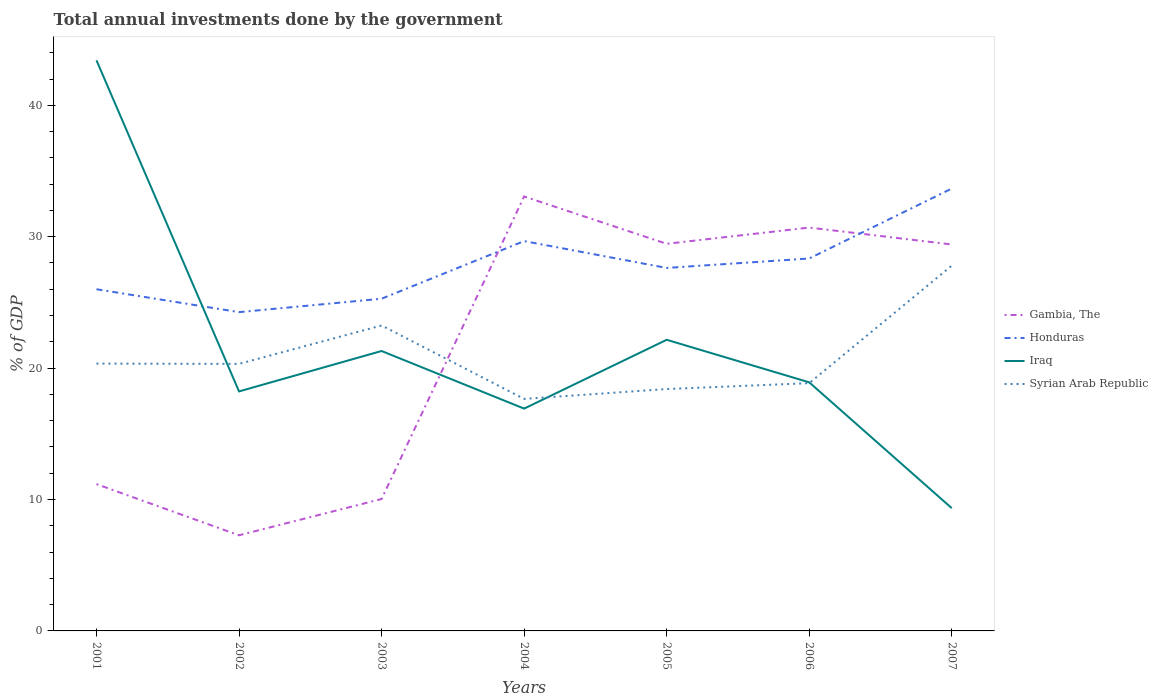Is the number of lines equal to the number of legend labels?
Your answer should be compact. Yes. Across all years, what is the maximum total annual investments done by the government in Gambia, The?
Your response must be concise. 7.28. In which year was the total annual investments done by the government in Iraq maximum?
Ensure brevity in your answer.  2007. What is the total total annual investments done by the government in Gambia, The in the graph?
Keep it short and to the point. 3.65. What is the difference between the highest and the second highest total annual investments done by the government in Syrian Arab Republic?
Make the answer very short. 10.14. What is the difference between the highest and the lowest total annual investments done by the government in Iraq?
Your response must be concise. 2. Is the total annual investments done by the government in Syrian Arab Republic strictly greater than the total annual investments done by the government in Gambia, The over the years?
Your answer should be compact. No. How many years are there in the graph?
Your answer should be very brief. 7. What is the difference between two consecutive major ticks on the Y-axis?
Provide a short and direct response. 10. Are the values on the major ticks of Y-axis written in scientific E-notation?
Your response must be concise. No. Does the graph contain any zero values?
Offer a terse response. No. How are the legend labels stacked?
Ensure brevity in your answer.  Vertical. What is the title of the graph?
Provide a succinct answer. Total annual investments done by the government. What is the label or title of the X-axis?
Provide a succinct answer. Years. What is the label or title of the Y-axis?
Ensure brevity in your answer.  % of GDP. What is the % of GDP of Gambia, The in 2001?
Ensure brevity in your answer.  11.17. What is the % of GDP of Honduras in 2001?
Your answer should be compact. 26. What is the % of GDP in Iraq in 2001?
Your answer should be compact. 43.42. What is the % of GDP in Syrian Arab Republic in 2001?
Ensure brevity in your answer.  20.34. What is the % of GDP of Gambia, The in 2002?
Provide a short and direct response. 7.28. What is the % of GDP of Honduras in 2002?
Offer a terse response. 24.26. What is the % of GDP in Iraq in 2002?
Offer a terse response. 18.23. What is the % of GDP of Syrian Arab Republic in 2002?
Provide a succinct answer. 20.32. What is the % of GDP of Gambia, The in 2003?
Provide a succinct answer. 10.04. What is the % of GDP in Honduras in 2003?
Give a very brief answer. 25.28. What is the % of GDP in Iraq in 2003?
Your response must be concise. 21.3. What is the % of GDP in Syrian Arab Republic in 2003?
Provide a short and direct response. 23.24. What is the % of GDP of Gambia, The in 2004?
Your response must be concise. 33.06. What is the % of GDP of Honduras in 2004?
Make the answer very short. 29.67. What is the % of GDP in Iraq in 2004?
Keep it short and to the point. 16.92. What is the % of GDP of Syrian Arab Republic in 2004?
Provide a short and direct response. 17.66. What is the % of GDP in Gambia, The in 2005?
Your answer should be compact. 29.46. What is the % of GDP in Honduras in 2005?
Your answer should be very brief. 27.62. What is the % of GDP of Iraq in 2005?
Your response must be concise. 22.16. What is the % of GDP of Syrian Arab Republic in 2005?
Keep it short and to the point. 18.41. What is the % of GDP of Gambia, The in 2006?
Provide a short and direct response. 30.7. What is the % of GDP of Honduras in 2006?
Keep it short and to the point. 28.34. What is the % of GDP in Iraq in 2006?
Make the answer very short. 18.92. What is the % of GDP of Syrian Arab Republic in 2006?
Your answer should be compact. 18.85. What is the % of GDP of Gambia, The in 2007?
Provide a short and direct response. 29.41. What is the % of GDP in Honduras in 2007?
Provide a short and direct response. 33.67. What is the % of GDP of Iraq in 2007?
Your response must be concise. 9.34. What is the % of GDP of Syrian Arab Republic in 2007?
Your answer should be compact. 27.8. Across all years, what is the maximum % of GDP in Gambia, The?
Keep it short and to the point. 33.06. Across all years, what is the maximum % of GDP in Honduras?
Ensure brevity in your answer.  33.67. Across all years, what is the maximum % of GDP in Iraq?
Keep it short and to the point. 43.42. Across all years, what is the maximum % of GDP in Syrian Arab Republic?
Your answer should be very brief. 27.8. Across all years, what is the minimum % of GDP of Gambia, The?
Your answer should be compact. 7.28. Across all years, what is the minimum % of GDP in Honduras?
Your answer should be very brief. 24.26. Across all years, what is the minimum % of GDP of Iraq?
Make the answer very short. 9.34. Across all years, what is the minimum % of GDP in Syrian Arab Republic?
Make the answer very short. 17.66. What is the total % of GDP of Gambia, The in the graph?
Give a very brief answer. 151.11. What is the total % of GDP in Honduras in the graph?
Keep it short and to the point. 194.84. What is the total % of GDP of Iraq in the graph?
Your answer should be compact. 150.28. What is the total % of GDP in Syrian Arab Republic in the graph?
Provide a succinct answer. 146.63. What is the difference between the % of GDP in Gambia, The in 2001 and that in 2002?
Your response must be concise. 3.89. What is the difference between the % of GDP of Honduras in 2001 and that in 2002?
Give a very brief answer. 1.74. What is the difference between the % of GDP in Iraq in 2001 and that in 2002?
Make the answer very short. 25.2. What is the difference between the % of GDP of Syrian Arab Republic in 2001 and that in 2002?
Your response must be concise. 0.02. What is the difference between the % of GDP of Gambia, The in 2001 and that in 2003?
Ensure brevity in your answer.  1.13. What is the difference between the % of GDP of Honduras in 2001 and that in 2003?
Give a very brief answer. 0.72. What is the difference between the % of GDP of Iraq in 2001 and that in 2003?
Ensure brevity in your answer.  22.12. What is the difference between the % of GDP of Syrian Arab Republic in 2001 and that in 2003?
Your response must be concise. -2.9. What is the difference between the % of GDP of Gambia, The in 2001 and that in 2004?
Your response must be concise. -21.89. What is the difference between the % of GDP in Honduras in 2001 and that in 2004?
Offer a very short reply. -3.66. What is the difference between the % of GDP of Iraq in 2001 and that in 2004?
Make the answer very short. 26.51. What is the difference between the % of GDP in Syrian Arab Republic in 2001 and that in 2004?
Give a very brief answer. 2.69. What is the difference between the % of GDP of Gambia, The in 2001 and that in 2005?
Keep it short and to the point. -18.29. What is the difference between the % of GDP of Honduras in 2001 and that in 2005?
Make the answer very short. -1.62. What is the difference between the % of GDP of Iraq in 2001 and that in 2005?
Your answer should be compact. 21.27. What is the difference between the % of GDP of Syrian Arab Republic in 2001 and that in 2005?
Provide a succinct answer. 1.94. What is the difference between the % of GDP in Gambia, The in 2001 and that in 2006?
Ensure brevity in your answer.  -19.52. What is the difference between the % of GDP of Honduras in 2001 and that in 2006?
Offer a terse response. -2.34. What is the difference between the % of GDP of Iraq in 2001 and that in 2006?
Provide a short and direct response. 24.5. What is the difference between the % of GDP of Syrian Arab Republic in 2001 and that in 2006?
Provide a short and direct response. 1.49. What is the difference between the % of GDP in Gambia, The in 2001 and that in 2007?
Give a very brief answer. -18.24. What is the difference between the % of GDP in Honduras in 2001 and that in 2007?
Offer a very short reply. -7.66. What is the difference between the % of GDP of Iraq in 2001 and that in 2007?
Give a very brief answer. 34.08. What is the difference between the % of GDP in Syrian Arab Republic in 2001 and that in 2007?
Give a very brief answer. -7.45. What is the difference between the % of GDP in Gambia, The in 2002 and that in 2003?
Offer a terse response. -2.76. What is the difference between the % of GDP in Honduras in 2002 and that in 2003?
Your answer should be very brief. -1.02. What is the difference between the % of GDP of Iraq in 2002 and that in 2003?
Your answer should be compact. -3.08. What is the difference between the % of GDP of Syrian Arab Republic in 2002 and that in 2003?
Your answer should be compact. -2.92. What is the difference between the % of GDP of Gambia, The in 2002 and that in 2004?
Your answer should be compact. -25.78. What is the difference between the % of GDP of Honduras in 2002 and that in 2004?
Your answer should be compact. -5.41. What is the difference between the % of GDP of Iraq in 2002 and that in 2004?
Offer a terse response. 1.31. What is the difference between the % of GDP in Syrian Arab Republic in 2002 and that in 2004?
Offer a terse response. 2.66. What is the difference between the % of GDP in Gambia, The in 2002 and that in 2005?
Give a very brief answer. -22.18. What is the difference between the % of GDP of Honduras in 2002 and that in 2005?
Your answer should be very brief. -3.36. What is the difference between the % of GDP in Iraq in 2002 and that in 2005?
Provide a short and direct response. -3.93. What is the difference between the % of GDP in Syrian Arab Republic in 2002 and that in 2005?
Make the answer very short. 1.91. What is the difference between the % of GDP in Gambia, The in 2002 and that in 2006?
Make the answer very short. -23.42. What is the difference between the % of GDP in Honduras in 2002 and that in 2006?
Provide a short and direct response. -4.08. What is the difference between the % of GDP of Iraq in 2002 and that in 2006?
Your response must be concise. -0.69. What is the difference between the % of GDP in Syrian Arab Republic in 2002 and that in 2006?
Your response must be concise. 1.47. What is the difference between the % of GDP of Gambia, The in 2002 and that in 2007?
Give a very brief answer. -22.13. What is the difference between the % of GDP of Honduras in 2002 and that in 2007?
Provide a succinct answer. -9.41. What is the difference between the % of GDP in Iraq in 2002 and that in 2007?
Make the answer very short. 8.89. What is the difference between the % of GDP in Syrian Arab Republic in 2002 and that in 2007?
Offer a very short reply. -7.48. What is the difference between the % of GDP of Gambia, The in 2003 and that in 2004?
Your answer should be compact. -23.02. What is the difference between the % of GDP in Honduras in 2003 and that in 2004?
Your response must be concise. -4.38. What is the difference between the % of GDP in Iraq in 2003 and that in 2004?
Make the answer very short. 4.38. What is the difference between the % of GDP of Syrian Arab Republic in 2003 and that in 2004?
Give a very brief answer. 5.59. What is the difference between the % of GDP of Gambia, The in 2003 and that in 2005?
Your response must be concise. -19.42. What is the difference between the % of GDP of Honduras in 2003 and that in 2005?
Your answer should be compact. -2.34. What is the difference between the % of GDP in Iraq in 2003 and that in 2005?
Provide a succinct answer. -0.85. What is the difference between the % of GDP of Syrian Arab Republic in 2003 and that in 2005?
Provide a short and direct response. 4.84. What is the difference between the % of GDP of Gambia, The in 2003 and that in 2006?
Ensure brevity in your answer.  -20.66. What is the difference between the % of GDP of Honduras in 2003 and that in 2006?
Keep it short and to the point. -3.06. What is the difference between the % of GDP of Iraq in 2003 and that in 2006?
Give a very brief answer. 2.38. What is the difference between the % of GDP of Syrian Arab Republic in 2003 and that in 2006?
Keep it short and to the point. 4.39. What is the difference between the % of GDP of Gambia, The in 2003 and that in 2007?
Keep it short and to the point. -19.37. What is the difference between the % of GDP of Honduras in 2003 and that in 2007?
Keep it short and to the point. -8.38. What is the difference between the % of GDP in Iraq in 2003 and that in 2007?
Give a very brief answer. 11.96. What is the difference between the % of GDP of Syrian Arab Republic in 2003 and that in 2007?
Your response must be concise. -4.55. What is the difference between the % of GDP of Gambia, The in 2004 and that in 2005?
Ensure brevity in your answer.  3.6. What is the difference between the % of GDP of Honduras in 2004 and that in 2005?
Give a very brief answer. 2.04. What is the difference between the % of GDP of Iraq in 2004 and that in 2005?
Offer a very short reply. -5.24. What is the difference between the % of GDP in Syrian Arab Republic in 2004 and that in 2005?
Ensure brevity in your answer.  -0.75. What is the difference between the % of GDP of Gambia, The in 2004 and that in 2006?
Give a very brief answer. 2.36. What is the difference between the % of GDP in Honduras in 2004 and that in 2006?
Provide a succinct answer. 1.32. What is the difference between the % of GDP of Iraq in 2004 and that in 2006?
Make the answer very short. -2. What is the difference between the % of GDP of Syrian Arab Republic in 2004 and that in 2006?
Ensure brevity in your answer.  -1.2. What is the difference between the % of GDP in Gambia, The in 2004 and that in 2007?
Your answer should be very brief. 3.65. What is the difference between the % of GDP of Honduras in 2004 and that in 2007?
Provide a succinct answer. -4. What is the difference between the % of GDP in Iraq in 2004 and that in 2007?
Keep it short and to the point. 7.58. What is the difference between the % of GDP in Syrian Arab Republic in 2004 and that in 2007?
Keep it short and to the point. -10.14. What is the difference between the % of GDP in Gambia, The in 2005 and that in 2006?
Provide a succinct answer. -1.24. What is the difference between the % of GDP of Honduras in 2005 and that in 2006?
Your answer should be compact. -0.72. What is the difference between the % of GDP in Iraq in 2005 and that in 2006?
Keep it short and to the point. 3.24. What is the difference between the % of GDP in Syrian Arab Republic in 2005 and that in 2006?
Provide a short and direct response. -0.45. What is the difference between the % of GDP of Gambia, The in 2005 and that in 2007?
Offer a terse response. 0.05. What is the difference between the % of GDP of Honduras in 2005 and that in 2007?
Your response must be concise. -6.04. What is the difference between the % of GDP of Iraq in 2005 and that in 2007?
Give a very brief answer. 12.81. What is the difference between the % of GDP of Syrian Arab Republic in 2005 and that in 2007?
Make the answer very short. -9.39. What is the difference between the % of GDP in Gambia, The in 2006 and that in 2007?
Your answer should be very brief. 1.29. What is the difference between the % of GDP in Honduras in 2006 and that in 2007?
Offer a terse response. -5.32. What is the difference between the % of GDP of Iraq in 2006 and that in 2007?
Your answer should be very brief. 9.58. What is the difference between the % of GDP in Syrian Arab Republic in 2006 and that in 2007?
Your answer should be very brief. -8.94. What is the difference between the % of GDP in Gambia, The in 2001 and the % of GDP in Honduras in 2002?
Give a very brief answer. -13.09. What is the difference between the % of GDP of Gambia, The in 2001 and the % of GDP of Iraq in 2002?
Keep it short and to the point. -7.05. What is the difference between the % of GDP of Gambia, The in 2001 and the % of GDP of Syrian Arab Republic in 2002?
Your answer should be very brief. -9.15. What is the difference between the % of GDP in Honduras in 2001 and the % of GDP in Iraq in 2002?
Make the answer very short. 7.77. What is the difference between the % of GDP in Honduras in 2001 and the % of GDP in Syrian Arab Republic in 2002?
Ensure brevity in your answer.  5.68. What is the difference between the % of GDP of Iraq in 2001 and the % of GDP of Syrian Arab Republic in 2002?
Your response must be concise. 23.1. What is the difference between the % of GDP in Gambia, The in 2001 and the % of GDP in Honduras in 2003?
Keep it short and to the point. -14.11. What is the difference between the % of GDP in Gambia, The in 2001 and the % of GDP in Iraq in 2003?
Offer a very short reply. -10.13. What is the difference between the % of GDP of Gambia, The in 2001 and the % of GDP of Syrian Arab Republic in 2003?
Offer a very short reply. -12.07. What is the difference between the % of GDP of Honduras in 2001 and the % of GDP of Iraq in 2003?
Your answer should be compact. 4.7. What is the difference between the % of GDP of Honduras in 2001 and the % of GDP of Syrian Arab Republic in 2003?
Your answer should be compact. 2.76. What is the difference between the % of GDP in Iraq in 2001 and the % of GDP in Syrian Arab Republic in 2003?
Give a very brief answer. 20.18. What is the difference between the % of GDP in Gambia, The in 2001 and the % of GDP in Honduras in 2004?
Make the answer very short. -18.49. What is the difference between the % of GDP of Gambia, The in 2001 and the % of GDP of Iraq in 2004?
Your answer should be compact. -5.74. What is the difference between the % of GDP of Gambia, The in 2001 and the % of GDP of Syrian Arab Republic in 2004?
Ensure brevity in your answer.  -6.48. What is the difference between the % of GDP in Honduras in 2001 and the % of GDP in Iraq in 2004?
Make the answer very short. 9.08. What is the difference between the % of GDP in Honduras in 2001 and the % of GDP in Syrian Arab Republic in 2004?
Offer a terse response. 8.34. What is the difference between the % of GDP of Iraq in 2001 and the % of GDP of Syrian Arab Republic in 2004?
Provide a succinct answer. 25.77. What is the difference between the % of GDP of Gambia, The in 2001 and the % of GDP of Honduras in 2005?
Make the answer very short. -16.45. What is the difference between the % of GDP of Gambia, The in 2001 and the % of GDP of Iraq in 2005?
Offer a very short reply. -10.98. What is the difference between the % of GDP of Gambia, The in 2001 and the % of GDP of Syrian Arab Republic in 2005?
Ensure brevity in your answer.  -7.23. What is the difference between the % of GDP of Honduras in 2001 and the % of GDP of Iraq in 2005?
Provide a succinct answer. 3.85. What is the difference between the % of GDP of Honduras in 2001 and the % of GDP of Syrian Arab Republic in 2005?
Offer a terse response. 7.59. What is the difference between the % of GDP of Iraq in 2001 and the % of GDP of Syrian Arab Republic in 2005?
Your answer should be compact. 25.02. What is the difference between the % of GDP of Gambia, The in 2001 and the % of GDP of Honduras in 2006?
Keep it short and to the point. -17.17. What is the difference between the % of GDP in Gambia, The in 2001 and the % of GDP in Iraq in 2006?
Your response must be concise. -7.74. What is the difference between the % of GDP in Gambia, The in 2001 and the % of GDP in Syrian Arab Republic in 2006?
Offer a terse response. -7.68. What is the difference between the % of GDP of Honduras in 2001 and the % of GDP of Iraq in 2006?
Make the answer very short. 7.08. What is the difference between the % of GDP in Honduras in 2001 and the % of GDP in Syrian Arab Republic in 2006?
Make the answer very short. 7.15. What is the difference between the % of GDP of Iraq in 2001 and the % of GDP of Syrian Arab Republic in 2006?
Provide a short and direct response. 24.57. What is the difference between the % of GDP in Gambia, The in 2001 and the % of GDP in Honduras in 2007?
Give a very brief answer. -22.49. What is the difference between the % of GDP of Gambia, The in 2001 and the % of GDP of Iraq in 2007?
Offer a very short reply. 1.83. What is the difference between the % of GDP of Gambia, The in 2001 and the % of GDP of Syrian Arab Republic in 2007?
Keep it short and to the point. -16.63. What is the difference between the % of GDP in Honduras in 2001 and the % of GDP in Iraq in 2007?
Make the answer very short. 16.66. What is the difference between the % of GDP in Honduras in 2001 and the % of GDP in Syrian Arab Republic in 2007?
Provide a short and direct response. -1.8. What is the difference between the % of GDP in Iraq in 2001 and the % of GDP in Syrian Arab Republic in 2007?
Keep it short and to the point. 15.62. What is the difference between the % of GDP of Gambia, The in 2002 and the % of GDP of Honduras in 2003?
Offer a very short reply. -18. What is the difference between the % of GDP of Gambia, The in 2002 and the % of GDP of Iraq in 2003?
Your answer should be very brief. -14.02. What is the difference between the % of GDP of Gambia, The in 2002 and the % of GDP of Syrian Arab Republic in 2003?
Offer a very short reply. -15.97. What is the difference between the % of GDP of Honduras in 2002 and the % of GDP of Iraq in 2003?
Offer a terse response. 2.96. What is the difference between the % of GDP in Honduras in 2002 and the % of GDP in Syrian Arab Republic in 2003?
Provide a short and direct response. 1.01. What is the difference between the % of GDP of Iraq in 2002 and the % of GDP of Syrian Arab Republic in 2003?
Offer a terse response. -5.02. What is the difference between the % of GDP of Gambia, The in 2002 and the % of GDP of Honduras in 2004?
Give a very brief answer. -22.39. What is the difference between the % of GDP of Gambia, The in 2002 and the % of GDP of Iraq in 2004?
Your answer should be compact. -9.64. What is the difference between the % of GDP in Gambia, The in 2002 and the % of GDP in Syrian Arab Republic in 2004?
Ensure brevity in your answer.  -10.38. What is the difference between the % of GDP of Honduras in 2002 and the % of GDP of Iraq in 2004?
Your answer should be compact. 7.34. What is the difference between the % of GDP in Honduras in 2002 and the % of GDP in Syrian Arab Republic in 2004?
Your answer should be compact. 6.6. What is the difference between the % of GDP in Iraq in 2002 and the % of GDP in Syrian Arab Republic in 2004?
Provide a short and direct response. 0.57. What is the difference between the % of GDP in Gambia, The in 2002 and the % of GDP in Honduras in 2005?
Ensure brevity in your answer.  -20.34. What is the difference between the % of GDP in Gambia, The in 2002 and the % of GDP in Iraq in 2005?
Ensure brevity in your answer.  -14.88. What is the difference between the % of GDP in Gambia, The in 2002 and the % of GDP in Syrian Arab Republic in 2005?
Make the answer very short. -11.13. What is the difference between the % of GDP of Honduras in 2002 and the % of GDP of Iraq in 2005?
Your response must be concise. 2.1. What is the difference between the % of GDP in Honduras in 2002 and the % of GDP in Syrian Arab Republic in 2005?
Provide a succinct answer. 5.85. What is the difference between the % of GDP of Iraq in 2002 and the % of GDP of Syrian Arab Republic in 2005?
Your answer should be compact. -0.18. What is the difference between the % of GDP of Gambia, The in 2002 and the % of GDP of Honduras in 2006?
Provide a succinct answer. -21.06. What is the difference between the % of GDP in Gambia, The in 2002 and the % of GDP in Iraq in 2006?
Provide a short and direct response. -11.64. What is the difference between the % of GDP in Gambia, The in 2002 and the % of GDP in Syrian Arab Republic in 2006?
Provide a short and direct response. -11.58. What is the difference between the % of GDP in Honduras in 2002 and the % of GDP in Iraq in 2006?
Provide a short and direct response. 5.34. What is the difference between the % of GDP in Honduras in 2002 and the % of GDP in Syrian Arab Republic in 2006?
Offer a very short reply. 5.4. What is the difference between the % of GDP of Iraq in 2002 and the % of GDP of Syrian Arab Republic in 2006?
Provide a short and direct response. -0.63. What is the difference between the % of GDP in Gambia, The in 2002 and the % of GDP in Honduras in 2007?
Ensure brevity in your answer.  -26.39. What is the difference between the % of GDP in Gambia, The in 2002 and the % of GDP in Iraq in 2007?
Provide a short and direct response. -2.06. What is the difference between the % of GDP of Gambia, The in 2002 and the % of GDP of Syrian Arab Republic in 2007?
Provide a succinct answer. -20.52. What is the difference between the % of GDP of Honduras in 2002 and the % of GDP of Iraq in 2007?
Offer a terse response. 14.92. What is the difference between the % of GDP in Honduras in 2002 and the % of GDP in Syrian Arab Republic in 2007?
Provide a succinct answer. -3.54. What is the difference between the % of GDP of Iraq in 2002 and the % of GDP of Syrian Arab Republic in 2007?
Make the answer very short. -9.57. What is the difference between the % of GDP of Gambia, The in 2003 and the % of GDP of Honduras in 2004?
Keep it short and to the point. -19.63. What is the difference between the % of GDP of Gambia, The in 2003 and the % of GDP of Iraq in 2004?
Ensure brevity in your answer.  -6.88. What is the difference between the % of GDP of Gambia, The in 2003 and the % of GDP of Syrian Arab Republic in 2004?
Your answer should be compact. -7.62. What is the difference between the % of GDP in Honduras in 2003 and the % of GDP in Iraq in 2004?
Your answer should be compact. 8.36. What is the difference between the % of GDP of Honduras in 2003 and the % of GDP of Syrian Arab Republic in 2004?
Your response must be concise. 7.62. What is the difference between the % of GDP in Iraq in 2003 and the % of GDP in Syrian Arab Republic in 2004?
Your response must be concise. 3.65. What is the difference between the % of GDP in Gambia, The in 2003 and the % of GDP in Honduras in 2005?
Provide a succinct answer. -17.58. What is the difference between the % of GDP in Gambia, The in 2003 and the % of GDP in Iraq in 2005?
Offer a very short reply. -12.12. What is the difference between the % of GDP in Gambia, The in 2003 and the % of GDP in Syrian Arab Republic in 2005?
Provide a succinct answer. -8.37. What is the difference between the % of GDP of Honduras in 2003 and the % of GDP of Iraq in 2005?
Your answer should be very brief. 3.13. What is the difference between the % of GDP in Honduras in 2003 and the % of GDP in Syrian Arab Republic in 2005?
Keep it short and to the point. 6.87. What is the difference between the % of GDP of Iraq in 2003 and the % of GDP of Syrian Arab Republic in 2005?
Keep it short and to the point. 2.9. What is the difference between the % of GDP of Gambia, The in 2003 and the % of GDP of Honduras in 2006?
Ensure brevity in your answer.  -18.3. What is the difference between the % of GDP in Gambia, The in 2003 and the % of GDP in Iraq in 2006?
Your response must be concise. -8.88. What is the difference between the % of GDP in Gambia, The in 2003 and the % of GDP in Syrian Arab Republic in 2006?
Your answer should be very brief. -8.82. What is the difference between the % of GDP of Honduras in 2003 and the % of GDP of Iraq in 2006?
Keep it short and to the point. 6.36. What is the difference between the % of GDP in Honduras in 2003 and the % of GDP in Syrian Arab Republic in 2006?
Provide a succinct answer. 6.43. What is the difference between the % of GDP in Iraq in 2003 and the % of GDP in Syrian Arab Republic in 2006?
Give a very brief answer. 2.45. What is the difference between the % of GDP of Gambia, The in 2003 and the % of GDP of Honduras in 2007?
Provide a succinct answer. -23.63. What is the difference between the % of GDP in Gambia, The in 2003 and the % of GDP in Iraq in 2007?
Provide a succinct answer. 0.7. What is the difference between the % of GDP of Gambia, The in 2003 and the % of GDP of Syrian Arab Republic in 2007?
Ensure brevity in your answer.  -17.76. What is the difference between the % of GDP in Honduras in 2003 and the % of GDP in Iraq in 2007?
Ensure brevity in your answer.  15.94. What is the difference between the % of GDP of Honduras in 2003 and the % of GDP of Syrian Arab Republic in 2007?
Offer a very short reply. -2.52. What is the difference between the % of GDP in Iraq in 2003 and the % of GDP in Syrian Arab Republic in 2007?
Offer a very short reply. -6.5. What is the difference between the % of GDP of Gambia, The in 2004 and the % of GDP of Honduras in 2005?
Your answer should be very brief. 5.44. What is the difference between the % of GDP of Gambia, The in 2004 and the % of GDP of Iraq in 2005?
Provide a succinct answer. 10.9. What is the difference between the % of GDP of Gambia, The in 2004 and the % of GDP of Syrian Arab Republic in 2005?
Ensure brevity in your answer.  14.65. What is the difference between the % of GDP in Honduras in 2004 and the % of GDP in Iraq in 2005?
Provide a succinct answer. 7.51. What is the difference between the % of GDP in Honduras in 2004 and the % of GDP in Syrian Arab Republic in 2005?
Offer a terse response. 11.26. What is the difference between the % of GDP in Iraq in 2004 and the % of GDP in Syrian Arab Republic in 2005?
Provide a succinct answer. -1.49. What is the difference between the % of GDP in Gambia, The in 2004 and the % of GDP in Honduras in 2006?
Provide a short and direct response. 4.72. What is the difference between the % of GDP in Gambia, The in 2004 and the % of GDP in Iraq in 2006?
Keep it short and to the point. 14.14. What is the difference between the % of GDP of Gambia, The in 2004 and the % of GDP of Syrian Arab Republic in 2006?
Provide a short and direct response. 14.21. What is the difference between the % of GDP in Honduras in 2004 and the % of GDP in Iraq in 2006?
Offer a terse response. 10.75. What is the difference between the % of GDP in Honduras in 2004 and the % of GDP in Syrian Arab Republic in 2006?
Keep it short and to the point. 10.81. What is the difference between the % of GDP of Iraq in 2004 and the % of GDP of Syrian Arab Republic in 2006?
Keep it short and to the point. -1.94. What is the difference between the % of GDP in Gambia, The in 2004 and the % of GDP in Honduras in 2007?
Keep it short and to the point. -0.61. What is the difference between the % of GDP of Gambia, The in 2004 and the % of GDP of Iraq in 2007?
Make the answer very short. 23.72. What is the difference between the % of GDP in Gambia, The in 2004 and the % of GDP in Syrian Arab Republic in 2007?
Provide a succinct answer. 5.26. What is the difference between the % of GDP of Honduras in 2004 and the % of GDP of Iraq in 2007?
Your answer should be compact. 20.32. What is the difference between the % of GDP of Honduras in 2004 and the % of GDP of Syrian Arab Republic in 2007?
Provide a succinct answer. 1.87. What is the difference between the % of GDP of Iraq in 2004 and the % of GDP of Syrian Arab Republic in 2007?
Give a very brief answer. -10.88. What is the difference between the % of GDP of Gambia, The in 2005 and the % of GDP of Honduras in 2006?
Your response must be concise. 1.12. What is the difference between the % of GDP in Gambia, The in 2005 and the % of GDP in Iraq in 2006?
Give a very brief answer. 10.54. What is the difference between the % of GDP of Gambia, The in 2005 and the % of GDP of Syrian Arab Republic in 2006?
Your answer should be very brief. 10.61. What is the difference between the % of GDP in Honduras in 2005 and the % of GDP in Iraq in 2006?
Provide a succinct answer. 8.71. What is the difference between the % of GDP in Honduras in 2005 and the % of GDP in Syrian Arab Republic in 2006?
Your answer should be very brief. 8.77. What is the difference between the % of GDP of Iraq in 2005 and the % of GDP of Syrian Arab Republic in 2006?
Give a very brief answer. 3.3. What is the difference between the % of GDP of Gambia, The in 2005 and the % of GDP of Honduras in 2007?
Offer a terse response. -4.21. What is the difference between the % of GDP of Gambia, The in 2005 and the % of GDP of Iraq in 2007?
Make the answer very short. 20.12. What is the difference between the % of GDP of Gambia, The in 2005 and the % of GDP of Syrian Arab Republic in 2007?
Give a very brief answer. 1.66. What is the difference between the % of GDP in Honduras in 2005 and the % of GDP in Iraq in 2007?
Offer a very short reply. 18.28. What is the difference between the % of GDP of Honduras in 2005 and the % of GDP of Syrian Arab Republic in 2007?
Give a very brief answer. -0.18. What is the difference between the % of GDP in Iraq in 2005 and the % of GDP in Syrian Arab Republic in 2007?
Your response must be concise. -5.64. What is the difference between the % of GDP in Gambia, The in 2006 and the % of GDP in Honduras in 2007?
Your answer should be very brief. -2.97. What is the difference between the % of GDP in Gambia, The in 2006 and the % of GDP in Iraq in 2007?
Keep it short and to the point. 21.35. What is the difference between the % of GDP of Gambia, The in 2006 and the % of GDP of Syrian Arab Republic in 2007?
Give a very brief answer. 2.9. What is the difference between the % of GDP in Honduras in 2006 and the % of GDP in Iraq in 2007?
Give a very brief answer. 19. What is the difference between the % of GDP in Honduras in 2006 and the % of GDP in Syrian Arab Republic in 2007?
Give a very brief answer. 0.54. What is the difference between the % of GDP of Iraq in 2006 and the % of GDP of Syrian Arab Republic in 2007?
Keep it short and to the point. -8.88. What is the average % of GDP of Gambia, The per year?
Your answer should be compact. 21.59. What is the average % of GDP in Honduras per year?
Your response must be concise. 27.83. What is the average % of GDP of Iraq per year?
Ensure brevity in your answer.  21.47. What is the average % of GDP of Syrian Arab Republic per year?
Make the answer very short. 20.95. In the year 2001, what is the difference between the % of GDP of Gambia, The and % of GDP of Honduras?
Your answer should be very brief. -14.83. In the year 2001, what is the difference between the % of GDP of Gambia, The and % of GDP of Iraq?
Ensure brevity in your answer.  -32.25. In the year 2001, what is the difference between the % of GDP in Gambia, The and % of GDP in Syrian Arab Republic?
Offer a terse response. -9.17. In the year 2001, what is the difference between the % of GDP in Honduras and % of GDP in Iraq?
Keep it short and to the point. -17.42. In the year 2001, what is the difference between the % of GDP of Honduras and % of GDP of Syrian Arab Republic?
Provide a succinct answer. 5.66. In the year 2001, what is the difference between the % of GDP of Iraq and % of GDP of Syrian Arab Republic?
Offer a terse response. 23.08. In the year 2002, what is the difference between the % of GDP of Gambia, The and % of GDP of Honduras?
Your answer should be very brief. -16.98. In the year 2002, what is the difference between the % of GDP in Gambia, The and % of GDP in Iraq?
Provide a succinct answer. -10.95. In the year 2002, what is the difference between the % of GDP of Gambia, The and % of GDP of Syrian Arab Republic?
Provide a succinct answer. -13.04. In the year 2002, what is the difference between the % of GDP in Honduras and % of GDP in Iraq?
Keep it short and to the point. 6.03. In the year 2002, what is the difference between the % of GDP in Honduras and % of GDP in Syrian Arab Republic?
Your answer should be very brief. 3.94. In the year 2002, what is the difference between the % of GDP in Iraq and % of GDP in Syrian Arab Republic?
Provide a short and direct response. -2.09. In the year 2003, what is the difference between the % of GDP in Gambia, The and % of GDP in Honduras?
Provide a succinct answer. -15.24. In the year 2003, what is the difference between the % of GDP of Gambia, The and % of GDP of Iraq?
Provide a succinct answer. -11.26. In the year 2003, what is the difference between the % of GDP of Gambia, The and % of GDP of Syrian Arab Republic?
Provide a succinct answer. -13.21. In the year 2003, what is the difference between the % of GDP in Honduras and % of GDP in Iraq?
Make the answer very short. 3.98. In the year 2003, what is the difference between the % of GDP of Honduras and % of GDP of Syrian Arab Republic?
Make the answer very short. 2.04. In the year 2003, what is the difference between the % of GDP of Iraq and % of GDP of Syrian Arab Republic?
Ensure brevity in your answer.  -1.94. In the year 2004, what is the difference between the % of GDP in Gambia, The and % of GDP in Honduras?
Provide a succinct answer. 3.39. In the year 2004, what is the difference between the % of GDP in Gambia, The and % of GDP in Iraq?
Ensure brevity in your answer.  16.14. In the year 2004, what is the difference between the % of GDP of Gambia, The and % of GDP of Syrian Arab Republic?
Your answer should be very brief. 15.4. In the year 2004, what is the difference between the % of GDP in Honduras and % of GDP in Iraq?
Your response must be concise. 12.75. In the year 2004, what is the difference between the % of GDP in Honduras and % of GDP in Syrian Arab Republic?
Provide a succinct answer. 12.01. In the year 2004, what is the difference between the % of GDP of Iraq and % of GDP of Syrian Arab Republic?
Provide a short and direct response. -0.74. In the year 2005, what is the difference between the % of GDP in Gambia, The and % of GDP in Honduras?
Offer a very short reply. 1.84. In the year 2005, what is the difference between the % of GDP in Gambia, The and % of GDP in Iraq?
Provide a succinct answer. 7.3. In the year 2005, what is the difference between the % of GDP of Gambia, The and % of GDP of Syrian Arab Republic?
Ensure brevity in your answer.  11.05. In the year 2005, what is the difference between the % of GDP of Honduras and % of GDP of Iraq?
Give a very brief answer. 5.47. In the year 2005, what is the difference between the % of GDP in Honduras and % of GDP in Syrian Arab Republic?
Provide a short and direct response. 9.22. In the year 2005, what is the difference between the % of GDP in Iraq and % of GDP in Syrian Arab Republic?
Ensure brevity in your answer.  3.75. In the year 2006, what is the difference between the % of GDP in Gambia, The and % of GDP in Honduras?
Give a very brief answer. 2.35. In the year 2006, what is the difference between the % of GDP of Gambia, The and % of GDP of Iraq?
Your answer should be very brief. 11.78. In the year 2006, what is the difference between the % of GDP in Gambia, The and % of GDP in Syrian Arab Republic?
Provide a short and direct response. 11.84. In the year 2006, what is the difference between the % of GDP of Honduras and % of GDP of Iraq?
Make the answer very short. 9.42. In the year 2006, what is the difference between the % of GDP of Honduras and % of GDP of Syrian Arab Republic?
Offer a very short reply. 9.49. In the year 2006, what is the difference between the % of GDP of Iraq and % of GDP of Syrian Arab Republic?
Offer a terse response. 0.06. In the year 2007, what is the difference between the % of GDP in Gambia, The and % of GDP in Honduras?
Offer a terse response. -4.26. In the year 2007, what is the difference between the % of GDP of Gambia, The and % of GDP of Iraq?
Your answer should be compact. 20.07. In the year 2007, what is the difference between the % of GDP of Gambia, The and % of GDP of Syrian Arab Republic?
Give a very brief answer. 1.61. In the year 2007, what is the difference between the % of GDP in Honduras and % of GDP in Iraq?
Offer a very short reply. 24.32. In the year 2007, what is the difference between the % of GDP of Honduras and % of GDP of Syrian Arab Republic?
Keep it short and to the point. 5.87. In the year 2007, what is the difference between the % of GDP in Iraq and % of GDP in Syrian Arab Republic?
Your answer should be compact. -18.46. What is the ratio of the % of GDP in Gambia, The in 2001 to that in 2002?
Offer a terse response. 1.54. What is the ratio of the % of GDP of Honduras in 2001 to that in 2002?
Offer a terse response. 1.07. What is the ratio of the % of GDP of Iraq in 2001 to that in 2002?
Your response must be concise. 2.38. What is the ratio of the % of GDP in Syrian Arab Republic in 2001 to that in 2002?
Provide a succinct answer. 1. What is the ratio of the % of GDP of Gambia, The in 2001 to that in 2003?
Your response must be concise. 1.11. What is the ratio of the % of GDP of Honduras in 2001 to that in 2003?
Your answer should be compact. 1.03. What is the ratio of the % of GDP of Iraq in 2001 to that in 2003?
Make the answer very short. 2.04. What is the ratio of the % of GDP in Syrian Arab Republic in 2001 to that in 2003?
Your answer should be very brief. 0.88. What is the ratio of the % of GDP of Gambia, The in 2001 to that in 2004?
Offer a very short reply. 0.34. What is the ratio of the % of GDP of Honduras in 2001 to that in 2004?
Provide a short and direct response. 0.88. What is the ratio of the % of GDP in Iraq in 2001 to that in 2004?
Keep it short and to the point. 2.57. What is the ratio of the % of GDP in Syrian Arab Republic in 2001 to that in 2004?
Provide a succinct answer. 1.15. What is the ratio of the % of GDP of Gambia, The in 2001 to that in 2005?
Offer a terse response. 0.38. What is the ratio of the % of GDP in Honduras in 2001 to that in 2005?
Your answer should be compact. 0.94. What is the ratio of the % of GDP in Iraq in 2001 to that in 2005?
Provide a short and direct response. 1.96. What is the ratio of the % of GDP of Syrian Arab Republic in 2001 to that in 2005?
Your response must be concise. 1.11. What is the ratio of the % of GDP of Gambia, The in 2001 to that in 2006?
Provide a succinct answer. 0.36. What is the ratio of the % of GDP of Honduras in 2001 to that in 2006?
Provide a succinct answer. 0.92. What is the ratio of the % of GDP of Iraq in 2001 to that in 2006?
Your response must be concise. 2.3. What is the ratio of the % of GDP of Syrian Arab Republic in 2001 to that in 2006?
Make the answer very short. 1.08. What is the ratio of the % of GDP in Gambia, The in 2001 to that in 2007?
Provide a succinct answer. 0.38. What is the ratio of the % of GDP of Honduras in 2001 to that in 2007?
Offer a terse response. 0.77. What is the ratio of the % of GDP of Iraq in 2001 to that in 2007?
Your answer should be very brief. 4.65. What is the ratio of the % of GDP in Syrian Arab Republic in 2001 to that in 2007?
Provide a short and direct response. 0.73. What is the ratio of the % of GDP in Gambia, The in 2002 to that in 2003?
Make the answer very short. 0.72. What is the ratio of the % of GDP of Honduras in 2002 to that in 2003?
Your answer should be compact. 0.96. What is the ratio of the % of GDP of Iraq in 2002 to that in 2003?
Your answer should be compact. 0.86. What is the ratio of the % of GDP in Syrian Arab Republic in 2002 to that in 2003?
Your answer should be compact. 0.87. What is the ratio of the % of GDP of Gambia, The in 2002 to that in 2004?
Provide a succinct answer. 0.22. What is the ratio of the % of GDP of Honduras in 2002 to that in 2004?
Your answer should be compact. 0.82. What is the ratio of the % of GDP of Iraq in 2002 to that in 2004?
Your answer should be compact. 1.08. What is the ratio of the % of GDP in Syrian Arab Republic in 2002 to that in 2004?
Your answer should be very brief. 1.15. What is the ratio of the % of GDP in Gambia, The in 2002 to that in 2005?
Give a very brief answer. 0.25. What is the ratio of the % of GDP of Honduras in 2002 to that in 2005?
Provide a short and direct response. 0.88. What is the ratio of the % of GDP in Iraq in 2002 to that in 2005?
Your answer should be compact. 0.82. What is the ratio of the % of GDP in Syrian Arab Republic in 2002 to that in 2005?
Keep it short and to the point. 1.1. What is the ratio of the % of GDP in Gambia, The in 2002 to that in 2006?
Your answer should be very brief. 0.24. What is the ratio of the % of GDP in Honduras in 2002 to that in 2006?
Provide a succinct answer. 0.86. What is the ratio of the % of GDP in Iraq in 2002 to that in 2006?
Offer a terse response. 0.96. What is the ratio of the % of GDP of Syrian Arab Republic in 2002 to that in 2006?
Keep it short and to the point. 1.08. What is the ratio of the % of GDP of Gambia, The in 2002 to that in 2007?
Your response must be concise. 0.25. What is the ratio of the % of GDP of Honduras in 2002 to that in 2007?
Ensure brevity in your answer.  0.72. What is the ratio of the % of GDP in Iraq in 2002 to that in 2007?
Ensure brevity in your answer.  1.95. What is the ratio of the % of GDP in Syrian Arab Republic in 2002 to that in 2007?
Your response must be concise. 0.73. What is the ratio of the % of GDP of Gambia, The in 2003 to that in 2004?
Give a very brief answer. 0.3. What is the ratio of the % of GDP of Honduras in 2003 to that in 2004?
Your answer should be very brief. 0.85. What is the ratio of the % of GDP in Iraq in 2003 to that in 2004?
Your response must be concise. 1.26. What is the ratio of the % of GDP in Syrian Arab Republic in 2003 to that in 2004?
Your response must be concise. 1.32. What is the ratio of the % of GDP of Gambia, The in 2003 to that in 2005?
Your answer should be very brief. 0.34. What is the ratio of the % of GDP of Honduras in 2003 to that in 2005?
Make the answer very short. 0.92. What is the ratio of the % of GDP in Iraq in 2003 to that in 2005?
Offer a very short reply. 0.96. What is the ratio of the % of GDP in Syrian Arab Republic in 2003 to that in 2005?
Your response must be concise. 1.26. What is the ratio of the % of GDP of Gambia, The in 2003 to that in 2006?
Your response must be concise. 0.33. What is the ratio of the % of GDP of Honduras in 2003 to that in 2006?
Your answer should be very brief. 0.89. What is the ratio of the % of GDP of Iraq in 2003 to that in 2006?
Give a very brief answer. 1.13. What is the ratio of the % of GDP in Syrian Arab Republic in 2003 to that in 2006?
Your answer should be compact. 1.23. What is the ratio of the % of GDP of Gambia, The in 2003 to that in 2007?
Your answer should be very brief. 0.34. What is the ratio of the % of GDP of Honduras in 2003 to that in 2007?
Offer a very short reply. 0.75. What is the ratio of the % of GDP of Iraq in 2003 to that in 2007?
Keep it short and to the point. 2.28. What is the ratio of the % of GDP of Syrian Arab Republic in 2003 to that in 2007?
Keep it short and to the point. 0.84. What is the ratio of the % of GDP of Gambia, The in 2004 to that in 2005?
Provide a succinct answer. 1.12. What is the ratio of the % of GDP in Honduras in 2004 to that in 2005?
Your answer should be compact. 1.07. What is the ratio of the % of GDP of Iraq in 2004 to that in 2005?
Keep it short and to the point. 0.76. What is the ratio of the % of GDP in Syrian Arab Republic in 2004 to that in 2005?
Your answer should be very brief. 0.96. What is the ratio of the % of GDP of Gambia, The in 2004 to that in 2006?
Your response must be concise. 1.08. What is the ratio of the % of GDP of Honduras in 2004 to that in 2006?
Offer a terse response. 1.05. What is the ratio of the % of GDP of Iraq in 2004 to that in 2006?
Ensure brevity in your answer.  0.89. What is the ratio of the % of GDP in Syrian Arab Republic in 2004 to that in 2006?
Make the answer very short. 0.94. What is the ratio of the % of GDP in Gambia, The in 2004 to that in 2007?
Your answer should be compact. 1.12. What is the ratio of the % of GDP in Honduras in 2004 to that in 2007?
Your response must be concise. 0.88. What is the ratio of the % of GDP of Iraq in 2004 to that in 2007?
Give a very brief answer. 1.81. What is the ratio of the % of GDP of Syrian Arab Republic in 2004 to that in 2007?
Offer a terse response. 0.64. What is the ratio of the % of GDP of Gambia, The in 2005 to that in 2006?
Offer a very short reply. 0.96. What is the ratio of the % of GDP of Honduras in 2005 to that in 2006?
Make the answer very short. 0.97. What is the ratio of the % of GDP of Iraq in 2005 to that in 2006?
Keep it short and to the point. 1.17. What is the ratio of the % of GDP of Syrian Arab Republic in 2005 to that in 2006?
Your answer should be very brief. 0.98. What is the ratio of the % of GDP of Gambia, The in 2005 to that in 2007?
Keep it short and to the point. 1. What is the ratio of the % of GDP in Honduras in 2005 to that in 2007?
Offer a very short reply. 0.82. What is the ratio of the % of GDP in Iraq in 2005 to that in 2007?
Make the answer very short. 2.37. What is the ratio of the % of GDP of Syrian Arab Republic in 2005 to that in 2007?
Provide a short and direct response. 0.66. What is the ratio of the % of GDP of Gambia, The in 2006 to that in 2007?
Make the answer very short. 1.04. What is the ratio of the % of GDP in Honduras in 2006 to that in 2007?
Your answer should be very brief. 0.84. What is the ratio of the % of GDP in Iraq in 2006 to that in 2007?
Give a very brief answer. 2.03. What is the ratio of the % of GDP in Syrian Arab Republic in 2006 to that in 2007?
Keep it short and to the point. 0.68. What is the difference between the highest and the second highest % of GDP of Gambia, The?
Offer a terse response. 2.36. What is the difference between the highest and the second highest % of GDP in Honduras?
Provide a short and direct response. 4. What is the difference between the highest and the second highest % of GDP in Iraq?
Provide a succinct answer. 21.27. What is the difference between the highest and the second highest % of GDP in Syrian Arab Republic?
Make the answer very short. 4.55. What is the difference between the highest and the lowest % of GDP in Gambia, The?
Your answer should be very brief. 25.78. What is the difference between the highest and the lowest % of GDP in Honduras?
Offer a very short reply. 9.41. What is the difference between the highest and the lowest % of GDP in Iraq?
Offer a terse response. 34.08. What is the difference between the highest and the lowest % of GDP in Syrian Arab Republic?
Make the answer very short. 10.14. 